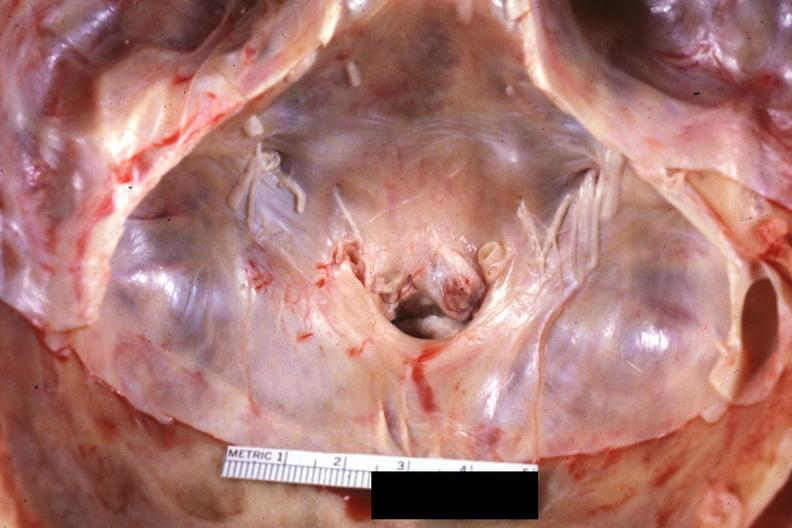s this good yellow color slide present?
Answer the question using a single word or phrase. No 